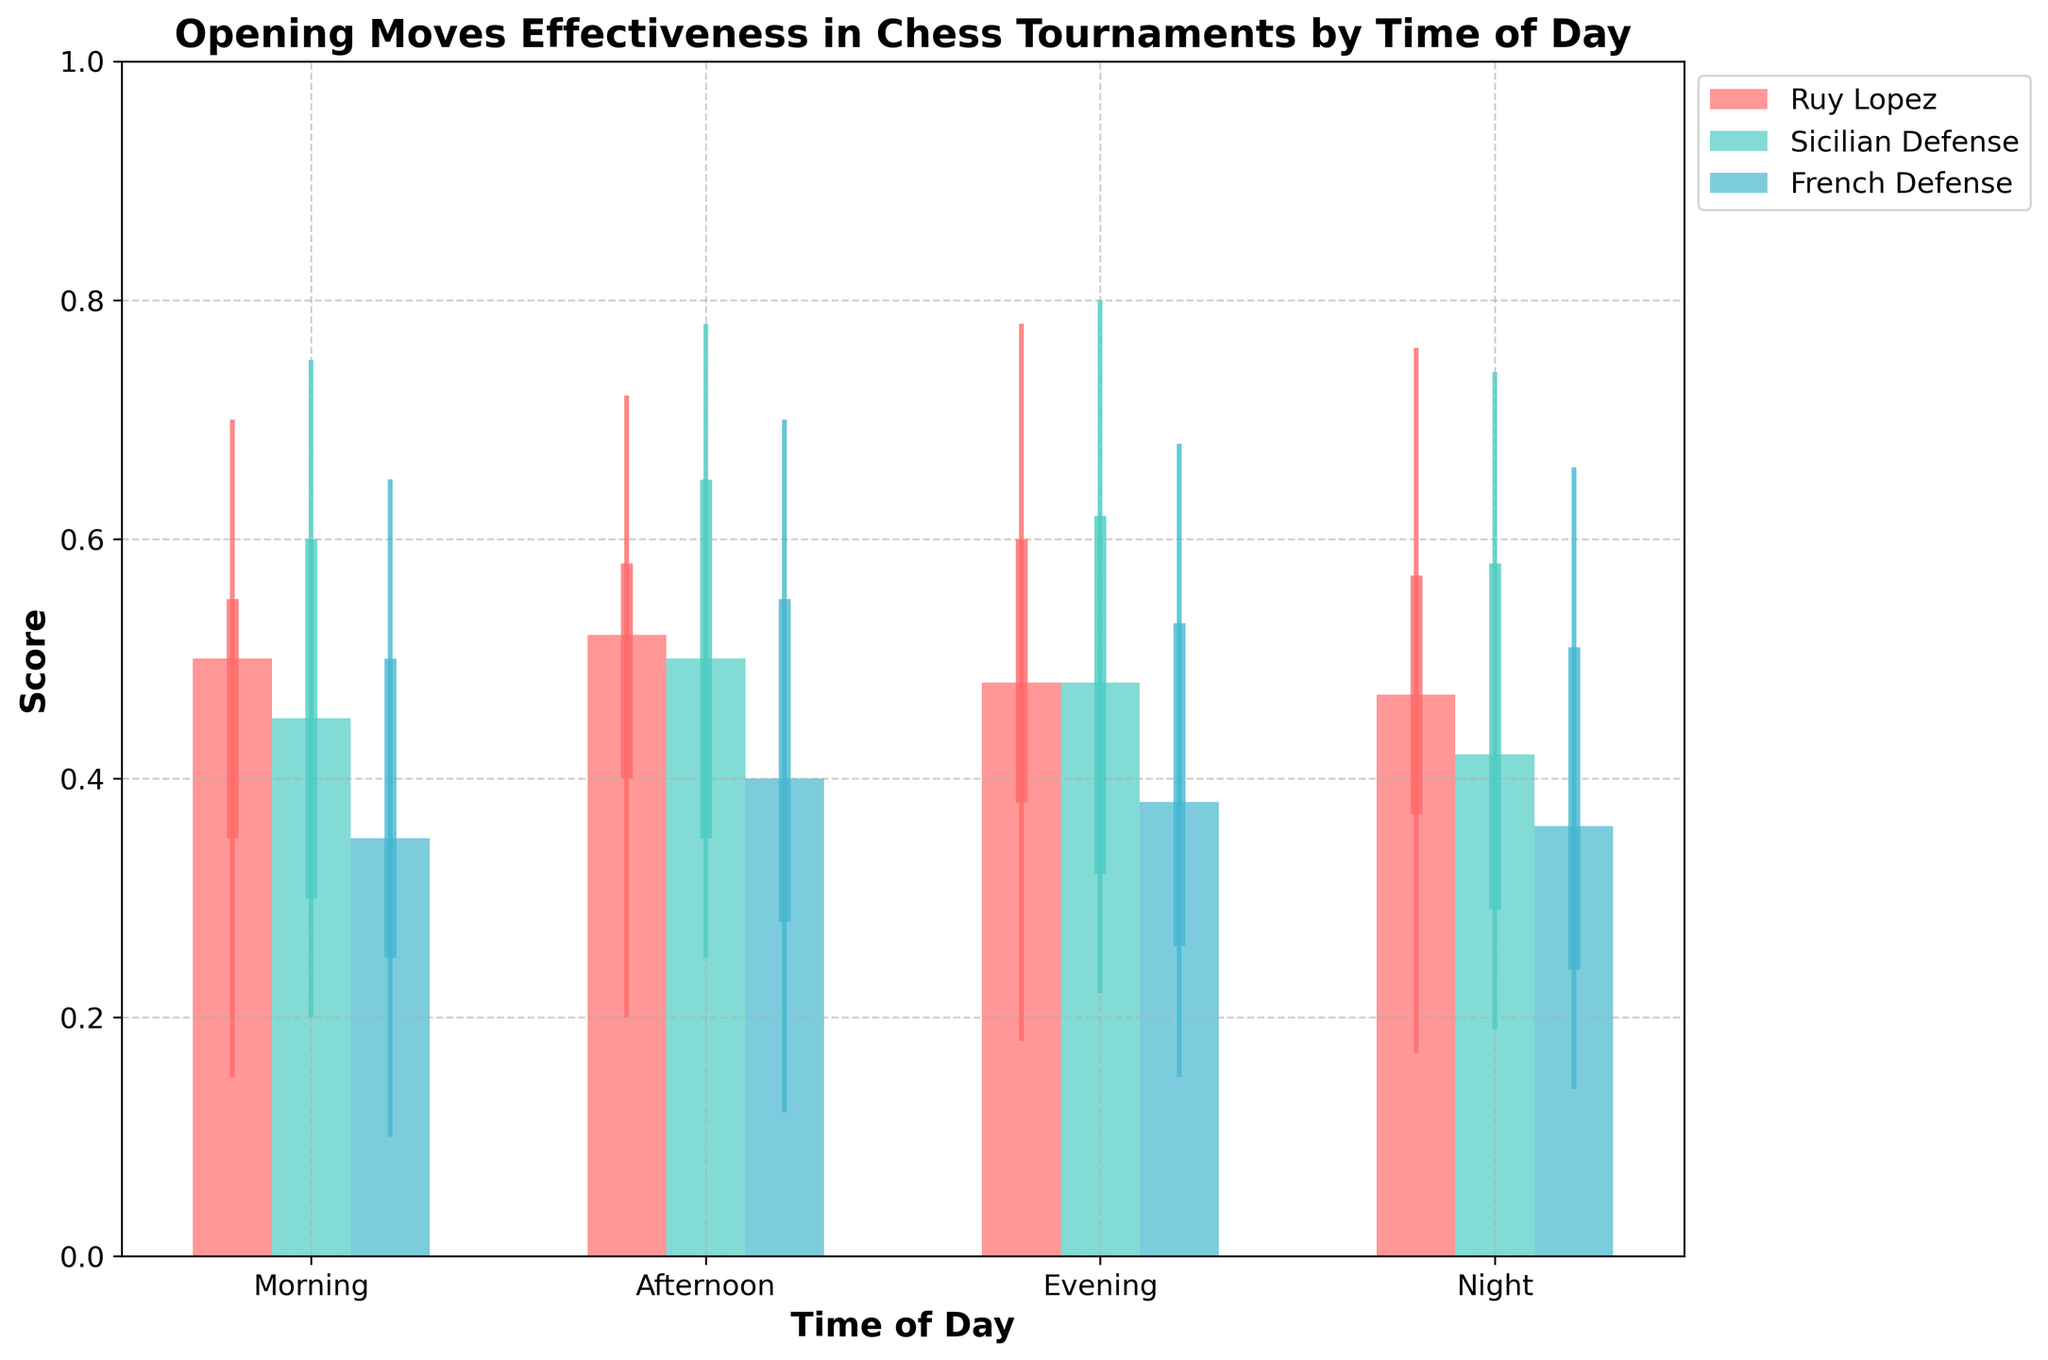What's the title of the figure? The title is usually displayed at the top of the figure in a larger and bold font. In this case, it is "Opening Moves Effectiveness in Chess Tournaments by Time of Day".
Answer: Opening Moves Effectiveness in Chess Tournaments by Time of Day What is the median score for the Sicilian Defense in the morning? To find the median score for the Sicilian Defense in the morning, locate the corresponding bar with the Sicilian Defense label and the time of day marked as morning. The height of the bar gives the median score, which is 0.45.
Answer: 0.45 Which opening has the highest maximum score in the evening? Look at the maximum scores (top of the vertical lines) for each opening in the evening section. Compare these maximum values, and the Sicilian Defense has the highest value at 0.80.
Answer: Sicilian Defense During which time of day does the French Defense have its lowest median score, and what is that score? Identify the bars corresponding to the French Defense across all times of day. Compare the median values (the heights of these bars) and find the lowest one, which is at night with a score of 0.36.
Answer: Night, 0.36 How does the range between the minimum and maximum scores for the Ruy Lopez in the afternoon compare to its range in the morning? Calculate the range by subtracting the minimum score from the maximum score for both time periods. For the afternoon, it is 0.72 - 0.20 = 0.52; for the morning, it is 0.70 - 0.15 = 0.55. Therefore, the range is slightly larger in the morning.
Answer: Morning range is larger What is the interquartile range (IQR) for the French Defense in the evening? The interquartile range (IQR) is the difference between the third quartile (Q3) and the first quartile (Q1). For the French Defense in the evening, Q3 is 0.53 and Q1 is 0.26. Thus, IQR = 0.53 - 0.26 = 0.27.
Answer: 0.27 Which opening strategy has the most consistent performance throughout the day, based on the smallest range between the minimum and maximum scores? Compare the ranges (max - min) for each opening over all times. The smallest range indicates the most consistent performance. The Ruy Lopez has ranges of 0.55, 0.52, 0.60, and 0.59, all close, but it seems less consistent than others. The French Defense with ranges of 0.55, 0.58, 0.53, and 0.52 is the most consistent.
Answer: French Defense In which time of day does the Ruy Lopez exhibit the highest median score, and what is that score? Locate the median bars for the Ruy Lopez for each time of day, and find the highest value. In the afternoon, the median is the highest at 0.52.
Answer: Afternoon, 0.52 